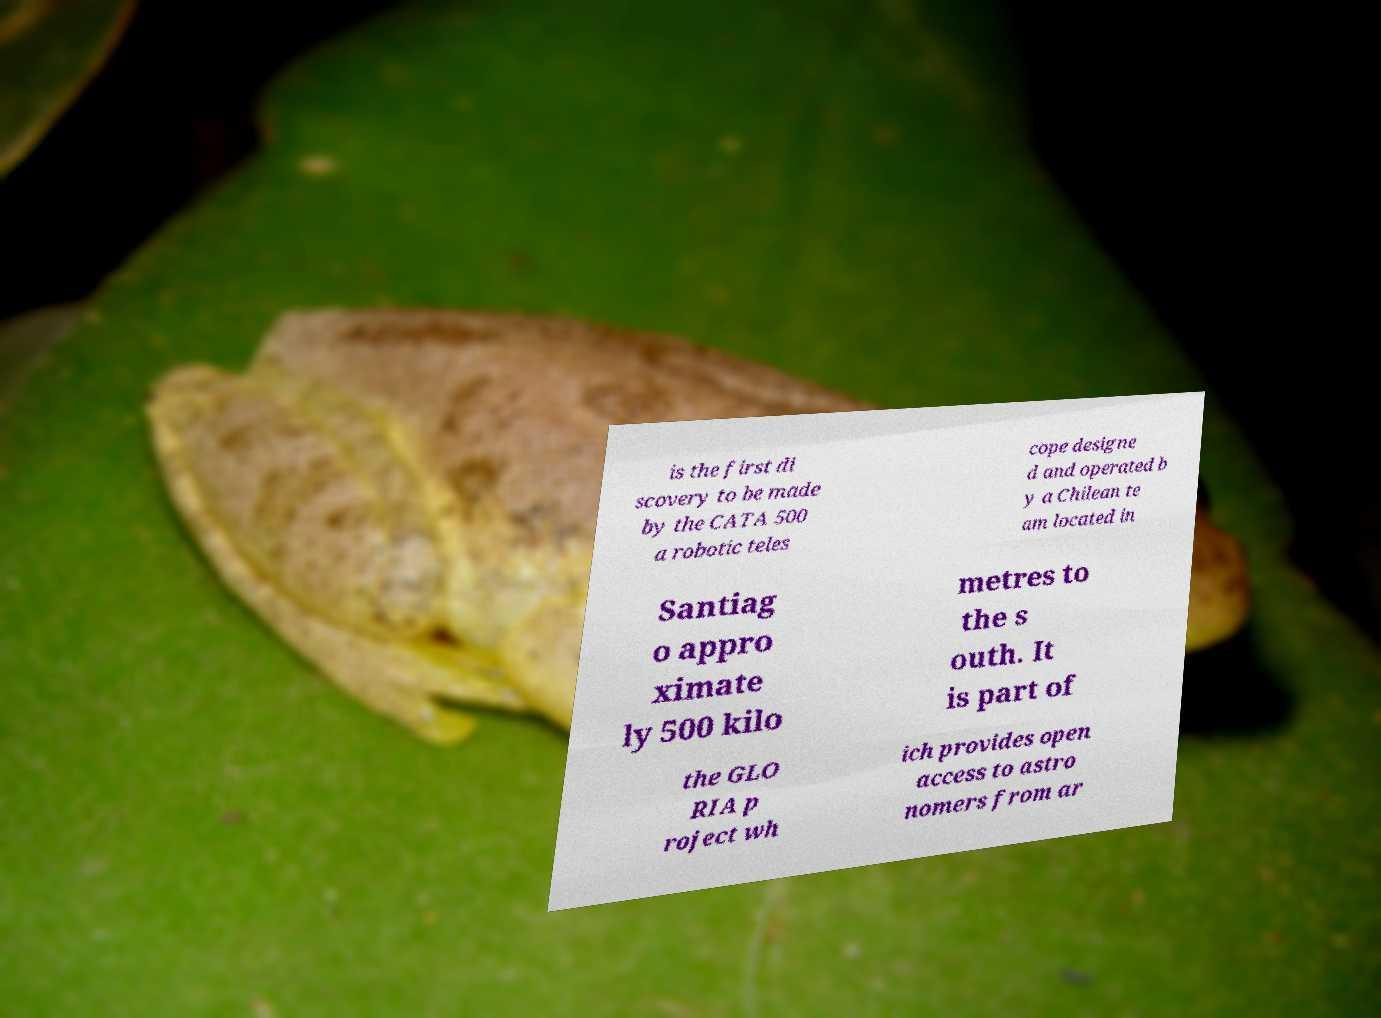Could you assist in decoding the text presented in this image and type it out clearly? is the first di scovery to be made by the CATA 500 a robotic teles cope designe d and operated b y a Chilean te am located in Santiag o appro ximate ly 500 kilo metres to the s outh. It is part of the GLO RIA p roject wh ich provides open access to astro nomers from ar 